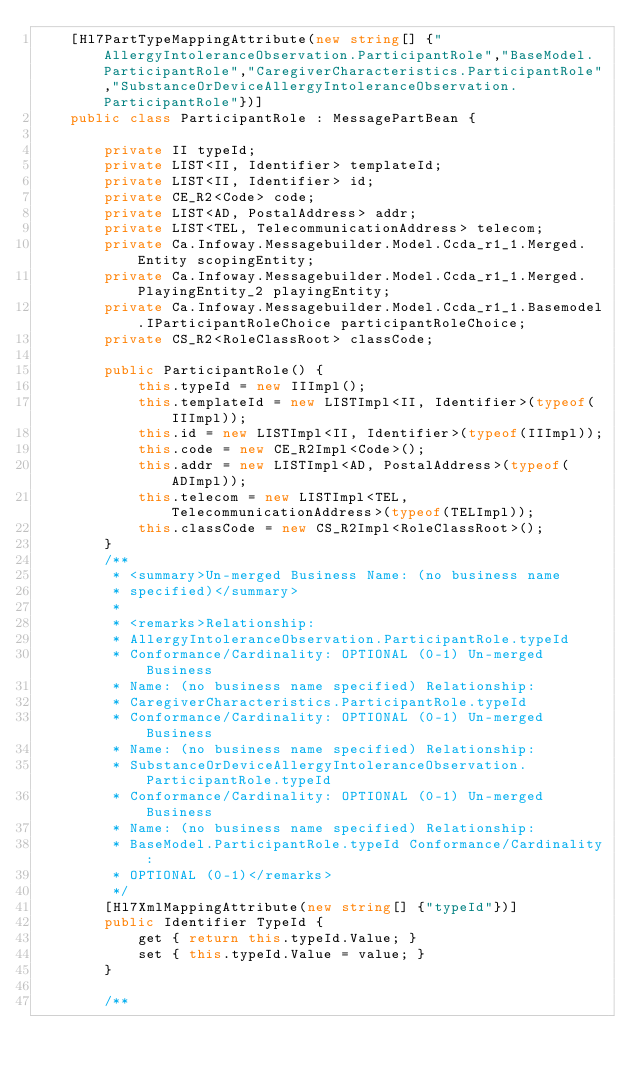Convert code to text. <code><loc_0><loc_0><loc_500><loc_500><_C#_>    [Hl7PartTypeMappingAttribute(new string[] {"AllergyIntoleranceObservation.ParticipantRole","BaseModel.ParticipantRole","CaregiverCharacteristics.ParticipantRole","SubstanceOrDeviceAllergyIntoleranceObservation.ParticipantRole"})]
    public class ParticipantRole : MessagePartBean {

        private II typeId;
        private LIST<II, Identifier> templateId;
        private LIST<II, Identifier> id;
        private CE_R2<Code> code;
        private LIST<AD, PostalAddress> addr;
        private LIST<TEL, TelecommunicationAddress> telecom;
        private Ca.Infoway.Messagebuilder.Model.Ccda_r1_1.Merged.Entity scopingEntity;
        private Ca.Infoway.Messagebuilder.Model.Ccda_r1_1.Merged.PlayingEntity_2 playingEntity;
        private Ca.Infoway.Messagebuilder.Model.Ccda_r1_1.Basemodel.IParticipantRoleChoice participantRoleChoice;
        private CS_R2<RoleClassRoot> classCode;

        public ParticipantRole() {
            this.typeId = new IIImpl();
            this.templateId = new LISTImpl<II, Identifier>(typeof(IIImpl));
            this.id = new LISTImpl<II, Identifier>(typeof(IIImpl));
            this.code = new CE_R2Impl<Code>();
            this.addr = new LISTImpl<AD, PostalAddress>(typeof(ADImpl));
            this.telecom = new LISTImpl<TEL, TelecommunicationAddress>(typeof(TELImpl));
            this.classCode = new CS_R2Impl<RoleClassRoot>();
        }
        /**
         * <summary>Un-merged Business Name: (no business name 
         * specified)</summary>
         * 
         * <remarks>Relationship: 
         * AllergyIntoleranceObservation.ParticipantRole.typeId 
         * Conformance/Cardinality: OPTIONAL (0-1) Un-merged Business 
         * Name: (no business name specified) Relationship: 
         * CaregiverCharacteristics.ParticipantRole.typeId 
         * Conformance/Cardinality: OPTIONAL (0-1) Un-merged Business 
         * Name: (no business name specified) Relationship: 
         * SubstanceOrDeviceAllergyIntoleranceObservation.ParticipantRole.typeId 
         * Conformance/Cardinality: OPTIONAL (0-1) Un-merged Business 
         * Name: (no business name specified) Relationship: 
         * BaseModel.ParticipantRole.typeId Conformance/Cardinality: 
         * OPTIONAL (0-1)</remarks>
         */
        [Hl7XmlMappingAttribute(new string[] {"typeId"})]
        public Identifier TypeId {
            get { return this.typeId.Value; }
            set { this.typeId.Value = value; }
        }

        /**</code> 